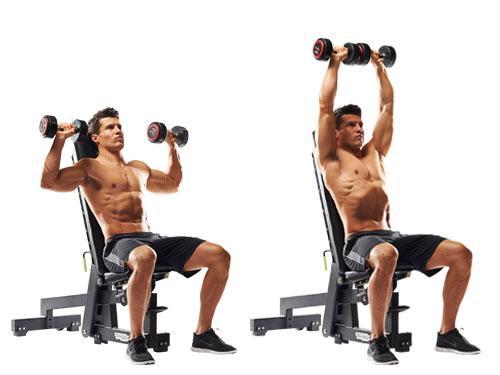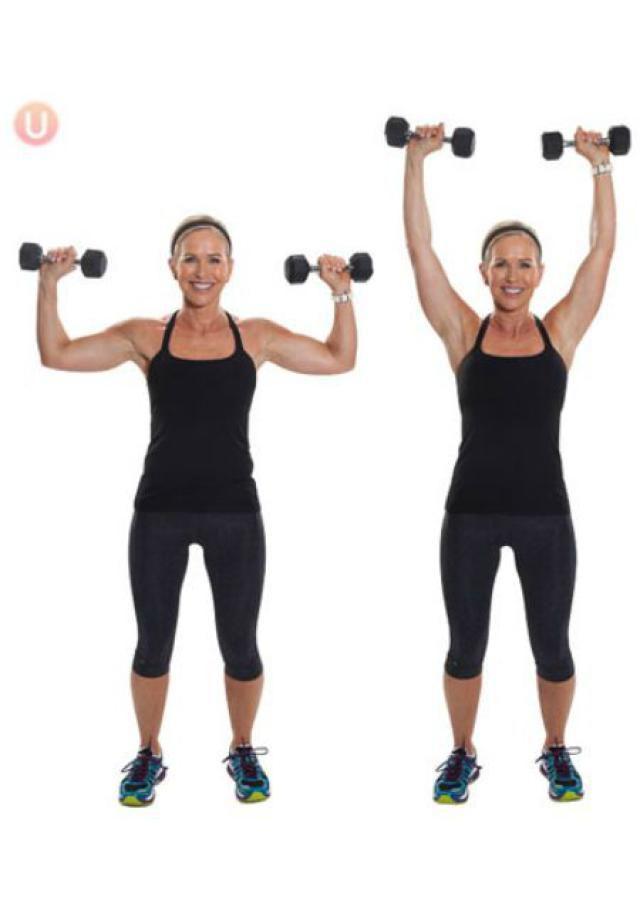The first image is the image on the left, the second image is the image on the right. Evaluate the accuracy of this statement regarding the images: "One image shows a woman doing weightlifting exercises". Is it true? Answer yes or no. Yes. 